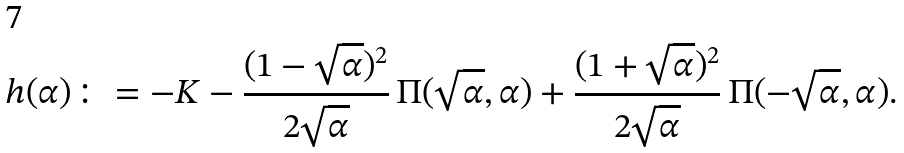<formula> <loc_0><loc_0><loc_500><loc_500>h ( \alpha ) \colon = - K - \frac { ( 1 - \sqrt { \alpha } ) ^ { 2 } } { 2 \sqrt { \alpha } } \, \Pi ( \sqrt { \alpha } , \alpha ) + \frac { ( 1 + \sqrt { \alpha } ) ^ { 2 } } { 2 \sqrt { \alpha } } \, \Pi ( - \sqrt { \alpha } , \alpha ) .</formula> 